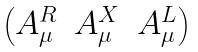Convert formula to latex. <formula><loc_0><loc_0><loc_500><loc_500>\begin{pmatrix} A ^ { R } _ { \mu } & A ^ { X } _ { \mu } & A ^ { L } _ { \mu } \end{pmatrix}</formula> 